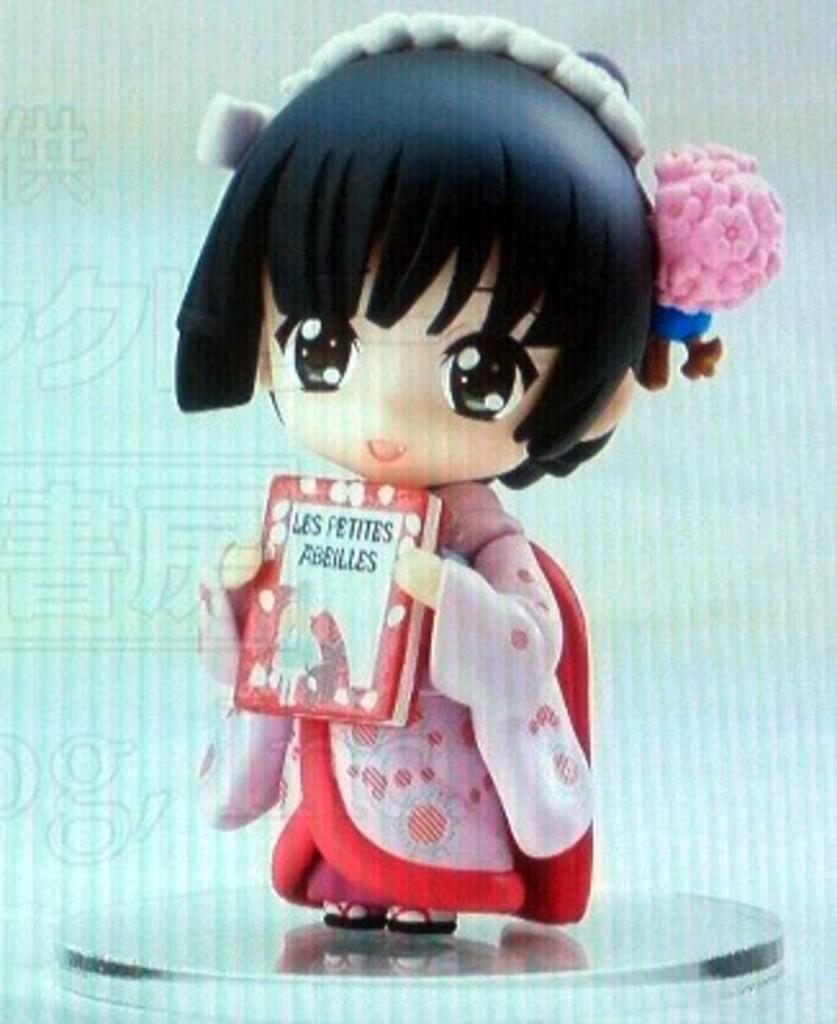How would you summarize this image in a sentence or two? In this image there is a doll, holding a box in the hands. It is placed on a metal surface. It is an edited image. 